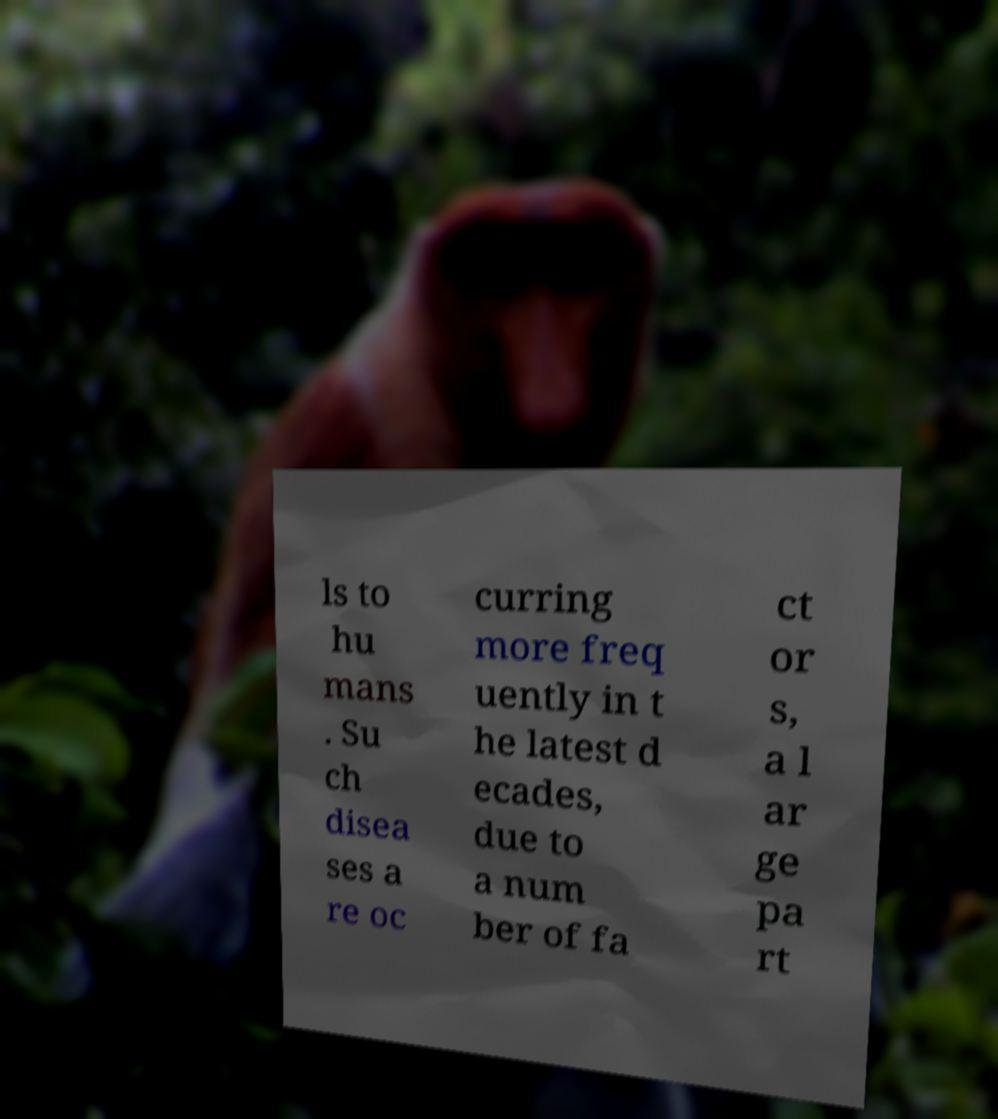I need the written content from this picture converted into text. Can you do that? ls to hu mans . Su ch disea ses a re oc curring more freq uently in t he latest d ecades, due to a num ber of fa ct or s, a l ar ge pa rt 